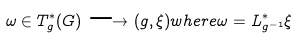Convert formula to latex. <formula><loc_0><loc_0><loc_500><loc_500>\omega \in T ^ { * } _ { g } ( G ) \longrightarrow ( g , \xi ) w h e r e \omega = L ^ { * } _ { g ^ { - 1 } } \xi</formula> 